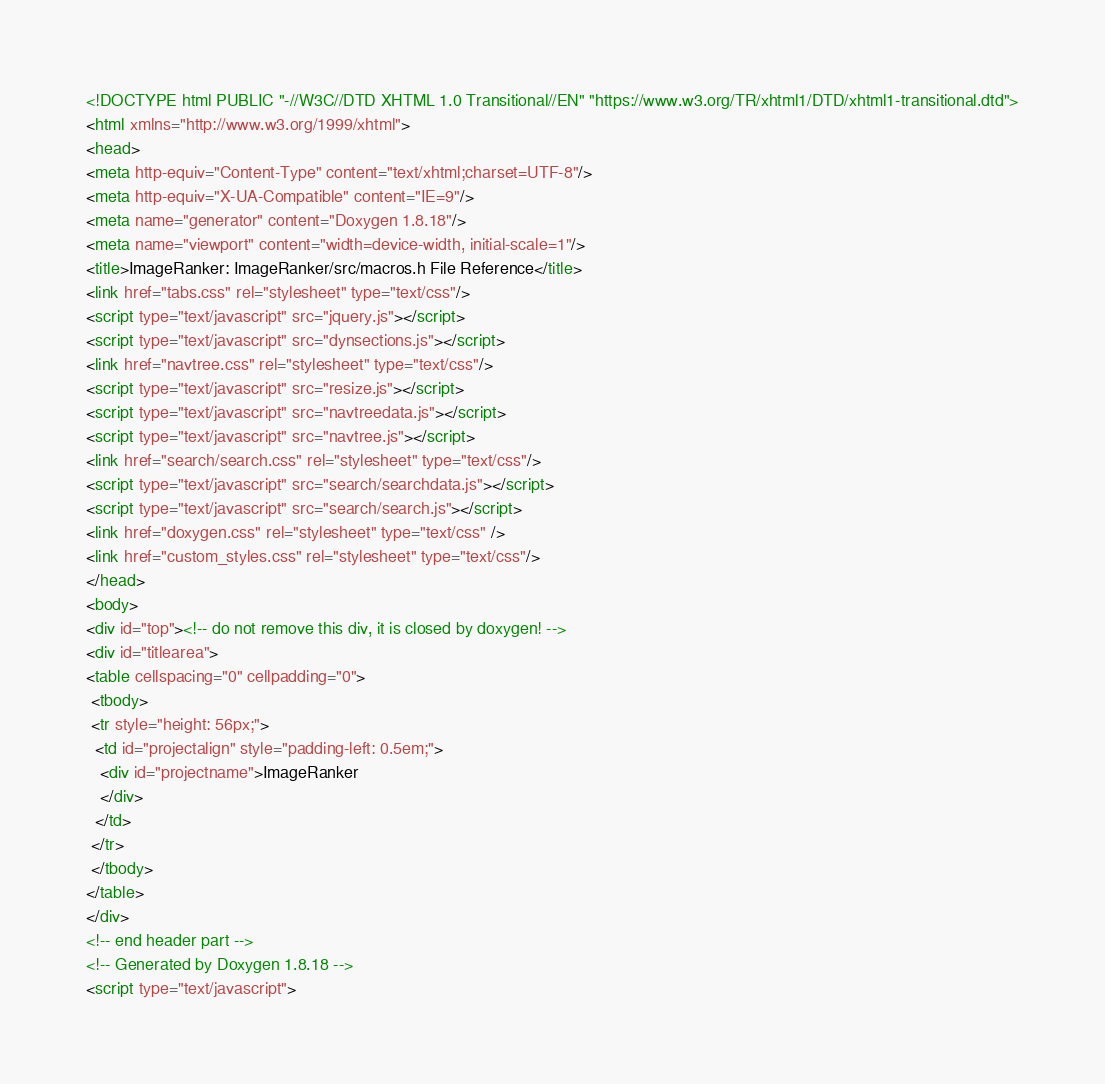<code> <loc_0><loc_0><loc_500><loc_500><_HTML_><!DOCTYPE html PUBLIC "-//W3C//DTD XHTML 1.0 Transitional//EN" "https://www.w3.org/TR/xhtml1/DTD/xhtml1-transitional.dtd">
<html xmlns="http://www.w3.org/1999/xhtml">
<head>
<meta http-equiv="Content-Type" content="text/xhtml;charset=UTF-8"/>
<meta http-equiv="X-UA-Compatible" content="IE=9"/>
<meta name="generator" content="Doxygen 1.8.18"/>
<meta name="viewport" content="width=device-width, initial-scale=1"/>
<title>ImageRanker: ImageRanker/src/macros.h File Reference</title>
<link href="tabs.css" rel="stylesheet" type="text/css"/>
<script type="text/javascript" src="jquery.js"></script>
<script type="text/javascript" src="dynsections.js"></script>
<link href="navtree.css" rel="stylesheet" type="text/css"/>
<script type="text/javascript" src="resize.js"></script>
<script type="text/javascript" src="navtreedata.js"></script>
<script type="text/javascript" src="navtree.js"></script>
<link href="search/search.css" rel="stylesheet" type="text/css"/>
<script type="text/javascript" src="search/searchdata.js"></script>
<script type="text/javascript" src="search/search.js"></script>
<link href="doxygen.css" rel="stylesheet" type="text/css" />
<link href="custom_styles.css" rel="stylesheet" type="text/css"/>
</head>
<body>
<div id="top"><!-- do not remove this div, it is closed by doxygen! -->
<div id="titlearea">
<table cellspacing="0" cellpadding="0">
 <tbody>
 <tr style="height: 56px;">
  <td id="projectalign" style="padding-left: 0.5em;">
   <div id="projectname">ImageRanker
   </div>
  </td>
 </tr>
 </tbody>
</table>
</div>
<!-- end header part -->
<!-- Generated by Doxygen 1.8.18 -->
<script type="text/javascript"></code> 